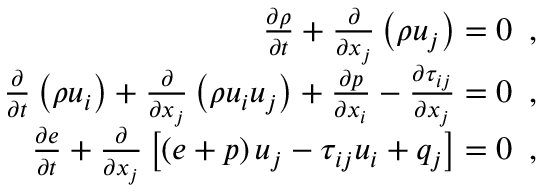<formula> <loc_0><loc_0><loc_500><loc_500>\begin{array} { r } { \frac { \partial \rho } { \partial t } + \frac { \partial } { \partial x _ { j } } \left ( \rho u _ { j } \right ) = 0 \, , } \\ { \frac { \partial } { \partial t } \left ( \rho u _ { i } \right ) + \frac { \partial } { \partial x _ { j } } \left ( \rho u _ { i } u _ { j } \right ) + \frac { \partial p } { \partial x _ { i } } - \frac { \partial \tau _ { i j } } { \partial x _ { j } } = 0 \, , } \\ { \frac { \partial e } { \partial t } + \frac { \partial } { \partial x _ { j } } \left [ \left ( e + p \right ) u _ { j } - \tau _ { i j } u _ { i } + q _ { j } \right ] = 0 \, , } \end{array}</formula> 